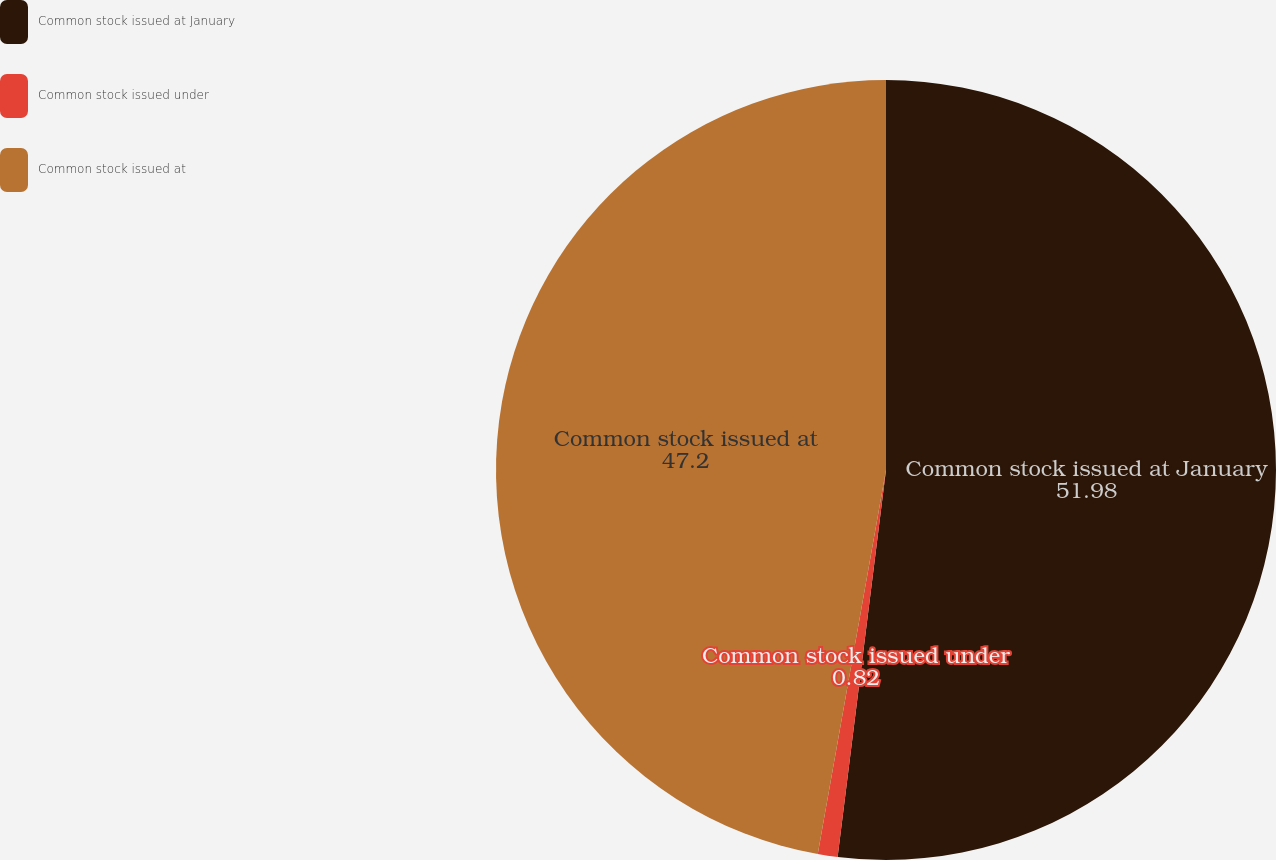Convert chart. <chart><loc_0><loc_0><loc_500><loc_500><pie_chart><fcel>Common stock issued at January<fcel>Common stock issued under<fcel>Common stock issued at<nl><fcel>51.98%<fcel>0.82%<fcel>47.2%<nl></chart> 